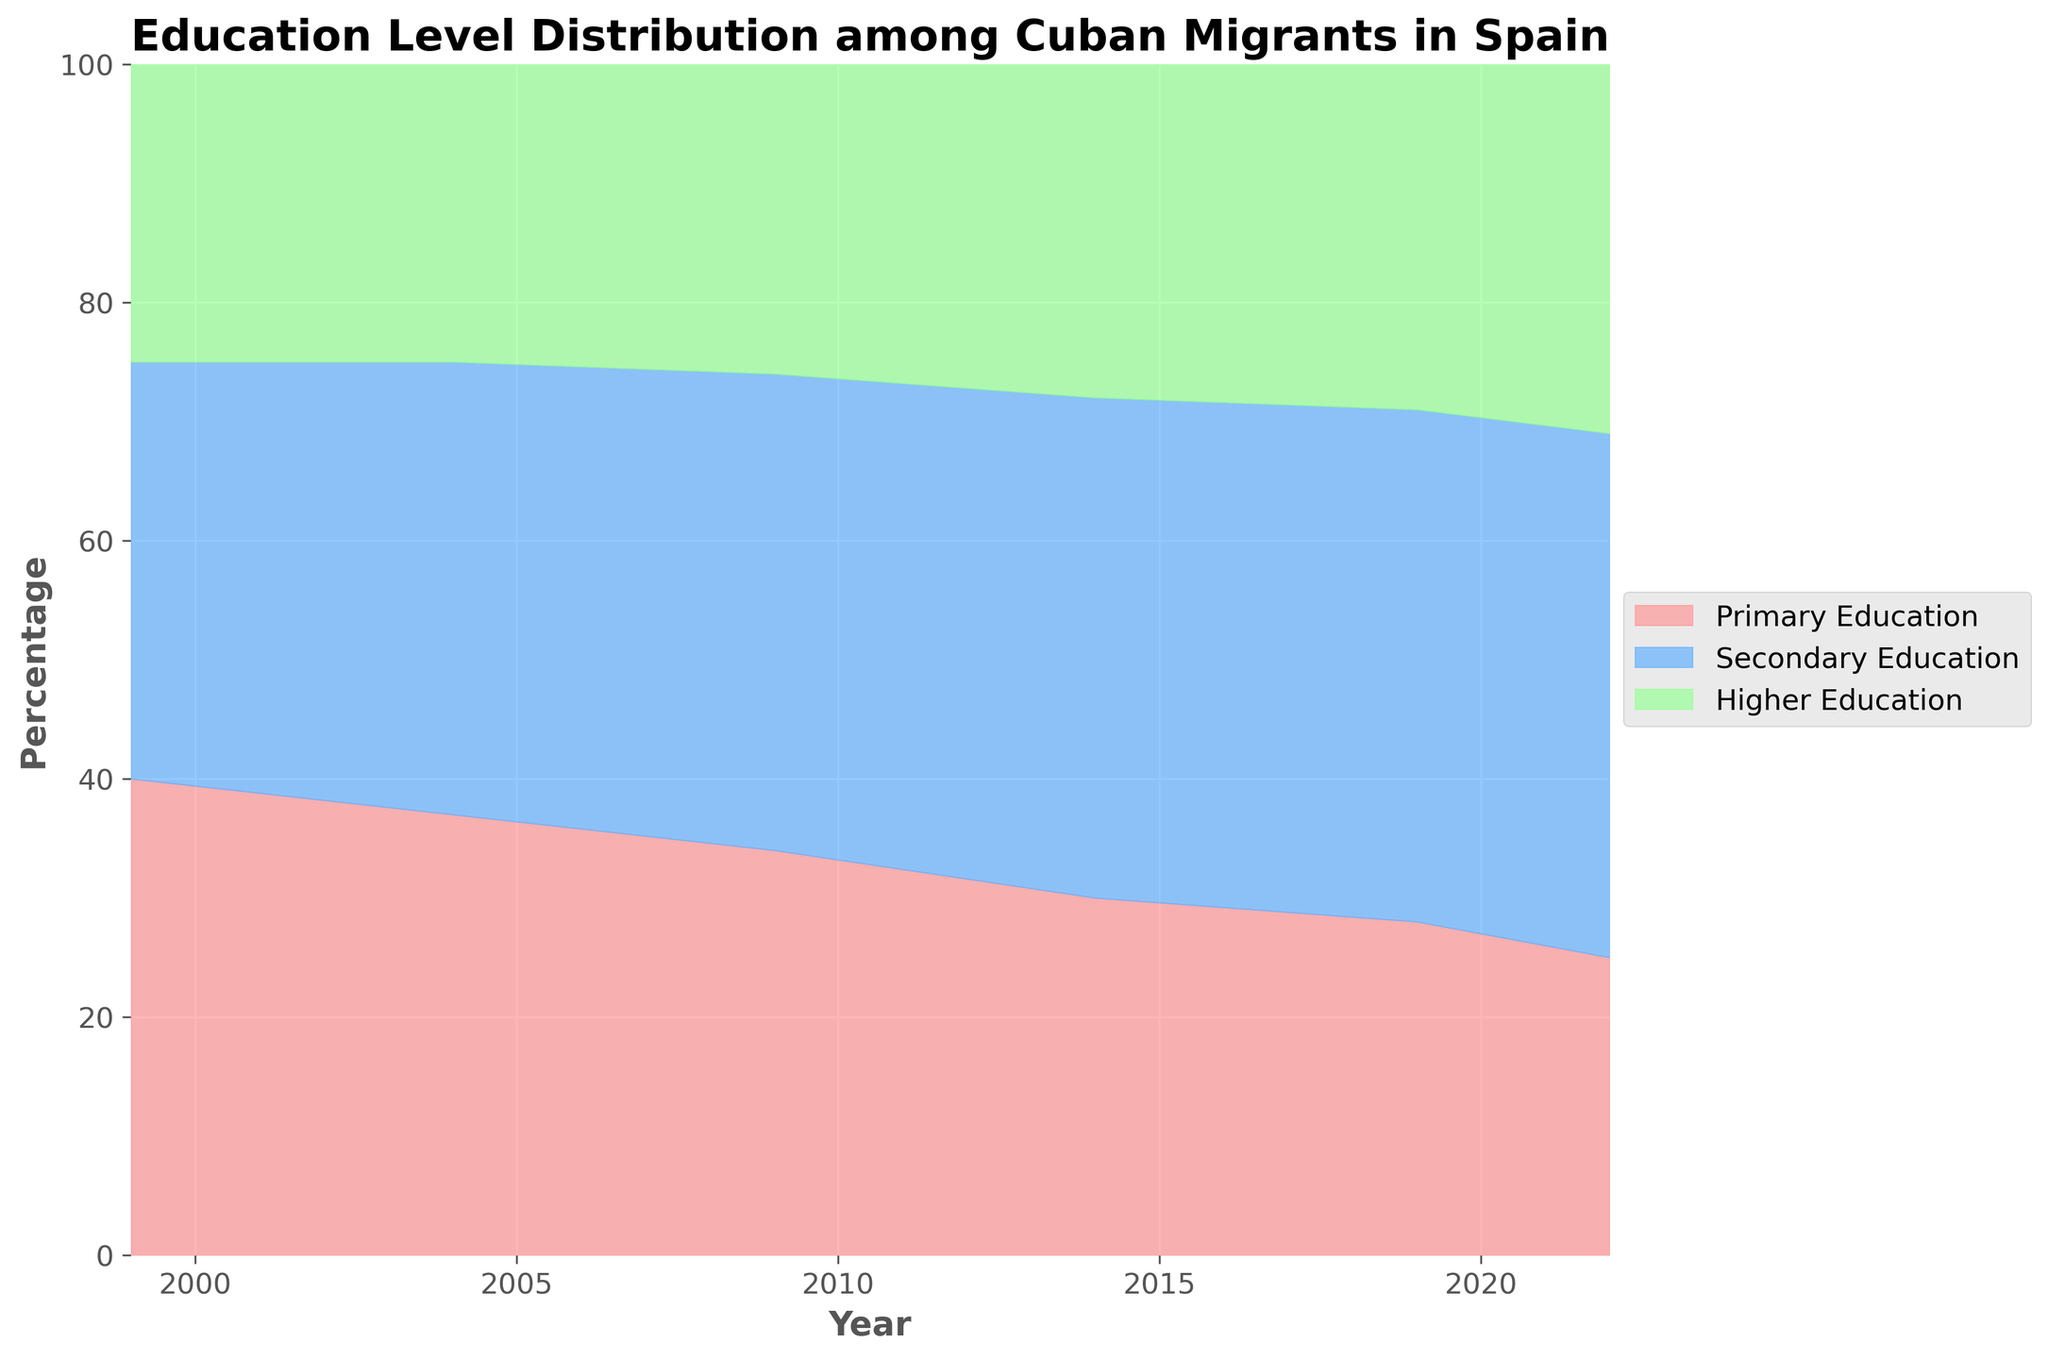What is the title of the figure? The title is always found at the top of the graph. In this case, it reads "Education Level Distribution among Cuban Migrants in Spain".
Answer: Education Level Distribution among Cuban Migrants in Spain What percentage of Cuban migrants had primary education in 1999? This can be directly read from the section of the graph corresponding to the year 1999. The section colored for primary education indicates 40%.
Answer: 40% How did the percentage of Cuban migrants with higher education change from 2004 to 2022? To find this, compare the values from 2004 and 2022 for higher education. In 2004, it was 25%, and in 2022, it increased to 31%. The change is 31% - 25% = 6%.
Answer: Increased by 6% What was the trend for secondary education among Cuban migrants from 1999 to 2022? Examine the section of the graph for secondary education and observe the upward trend in percentage from 35% in 1999 to 44% in 2022.
Answer: Upward trend Which education level showed the most significant increase over the years? Compare the net change for each education level from 1999 to 2022. Higher education increased from 25% to 31% (6% increase), primary education decreased from 40% to 25% (15% decrease), and secondary education increased from 35% to 44% (9% increase). Thus, secondary education had the most significant increase.
Answer: Secondary Education Which year had the highest percentage of Cuban migrants with higher education? Look at the graph section for higher education and identify the peak point, which occurs in 2022 at 31%.
Answer: 2022 In 2019, what was the combined percentage of Cuban migrants with secondary and higher education? This involves summing the individual percentages of secondary (43%) and higher education (29%) for the year 2019. 43% + 29% = 72%.
Answer: 72% From 1999 to 2022, which education level consistently decreased? Observe the trend lines for each education level over the years. Primary education is the one that consistently decreased from 40% in 1999 to 25% in 2022.
Answer: Primary Education In which year did the percentage of individuals with primary education drop below 30%? Read from the graph and identify the year when the percentage of primary education is first below 30%, which happens in 2019.
Answer: 2019 